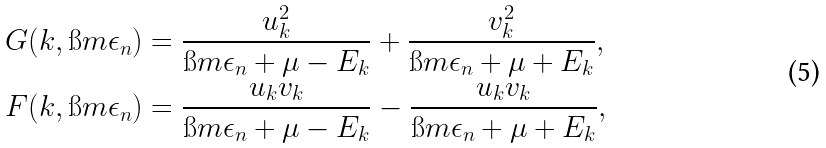<formula> <loc_0><loc_0><loc_500><loc_500>G ( k , \i m \epsilon _ { n } ) & = \frac { u _ { k } ^ { 2 } } { \i m \epsilon _ { n } + \mu - E _ { k } } + \frac { v _ { k } ^ { 2 } } { \i m \epsilon _ { n } + \mu + E _ { k } } , \\ F ( k , \i m \epsilon _ { n } ) & = \frac { u _ { k } v _ { k } } { \i m \epsilon _ { n } + \mu - E _ { k } } - \frac { u _ { k } v _ { k } } { \i m \epsilon _ { n } + \mu + E _ { k } } ,</formula> 